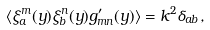Convert formula to latex. <formula><loc_0><loc_0><loc_500><loc_500>\langle \xi _ { a } ^ { m } ( y ) \xi _ { b } ^ { n } ( y ) g ^ { \prime } _ { m n } ( y ) \rangle = k ^ { 2 } \delta _ { a b } ,</formula> 